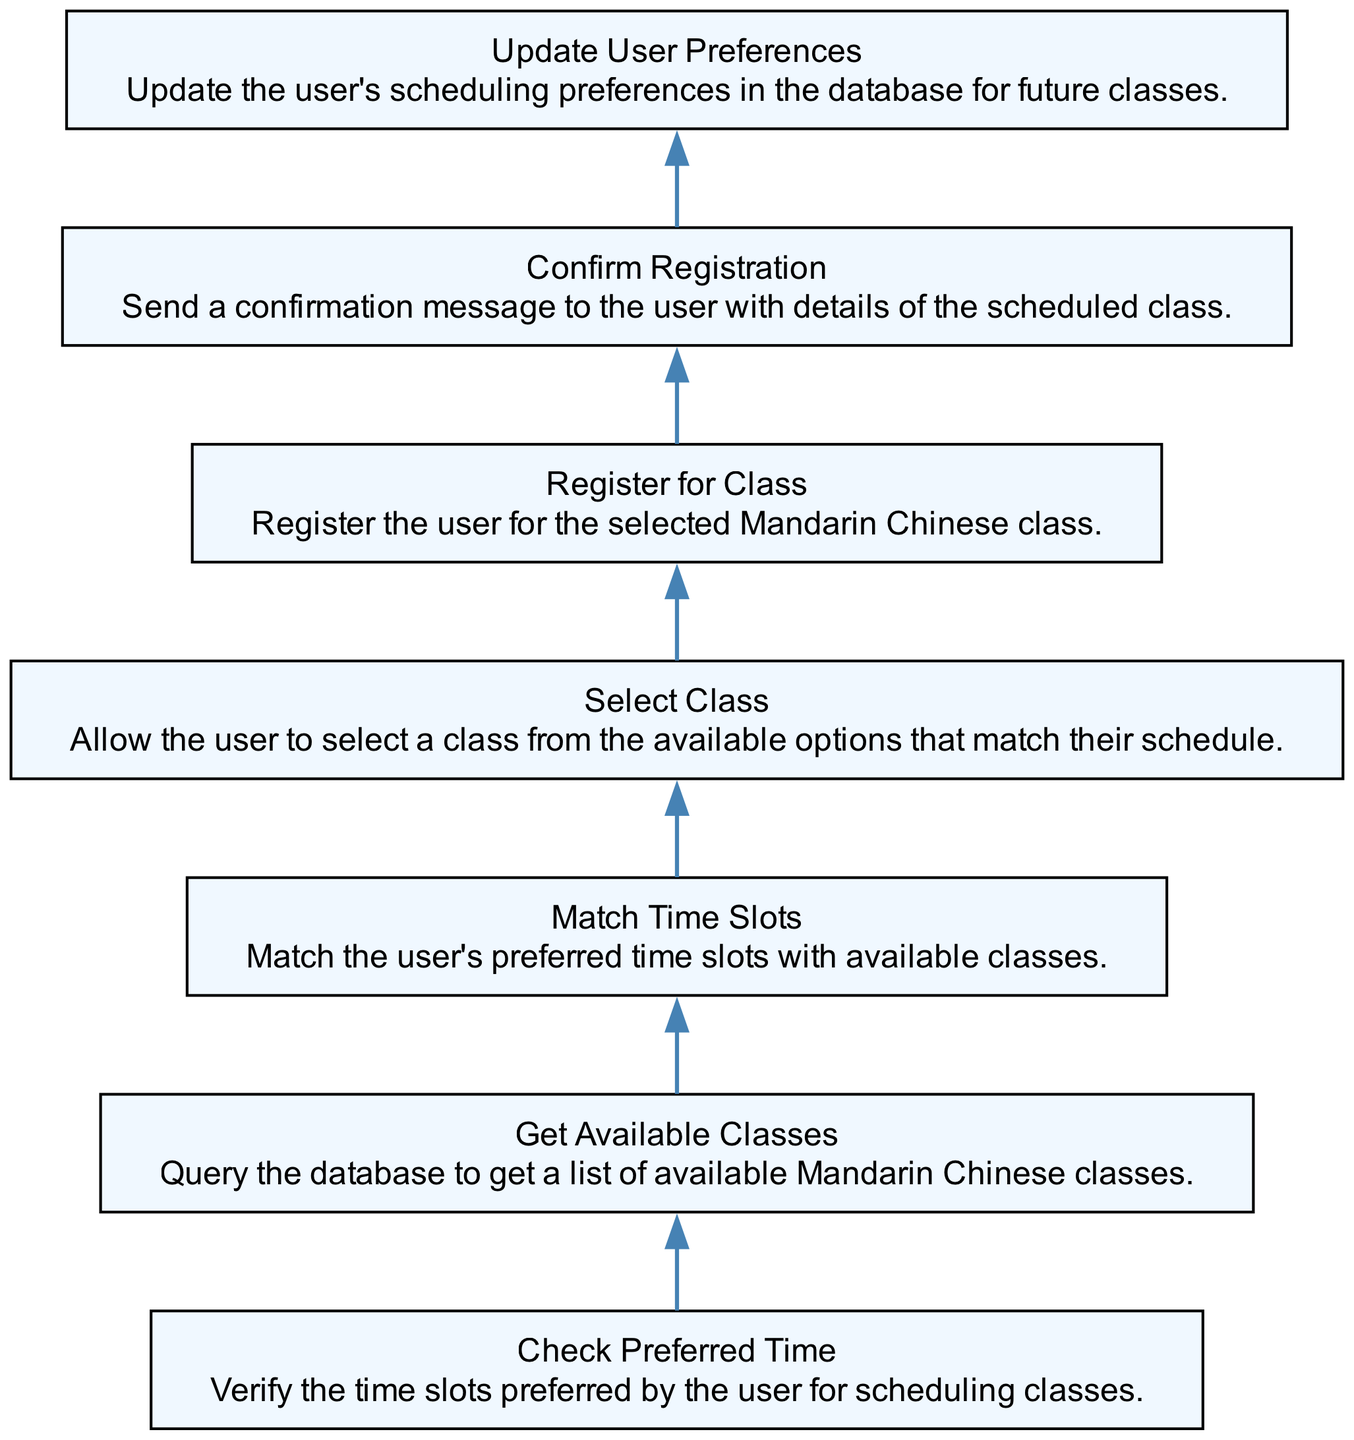What is the first step in the diagram? The first step is "Check Preferred Time," indicating the initial action to verify the user's preferred time slots for scheduling classes.
Answer: Check Preferred Time How many nodes are there in the diagram? The diagram contains seven nodes, each representing a different step in the scheduling process.
Answer: Seven What node follows "Get Available Classes"? "Match Time Slots" is the next node that follows "Get Available Classes," showing the order of operations in the scheduling process.
Answer: Match Time Slots Which step comes before "Confirm Registration"? "Register for Class" comes just before "Confirm Registration," indicating that registration must occur prior to sending confirmation.
Answer: Register for Class What action updates user information? "Update User Preferences" is the action that updates the user's scheduling preferences stored in the database for future classes.
Answer: Update User Preferences Which two steps are connected directly? "Select Class" and "Register for Class" are directly connected, indicating a flow between selecting an available class and registering for it.
Answer: Select Class and Register for Class What is the final step in the process? The final step is "Confirm Registration," which sends confirmation details to the user regarding their scheduled class.
Answer: Confirm Registration How does "Match Time Slots" relate to "Get Available Classes"? "Match Time Slots" relies on the output of "Get Available Classes" to align the user's preferred times with the available classes.
Answer: Match Time Slots depends on Get Available Classes What action occurs after selecting a class? After selecting a class, the next action is to register for that class, following the flow from selection to registration.
Answer: Register for Class 